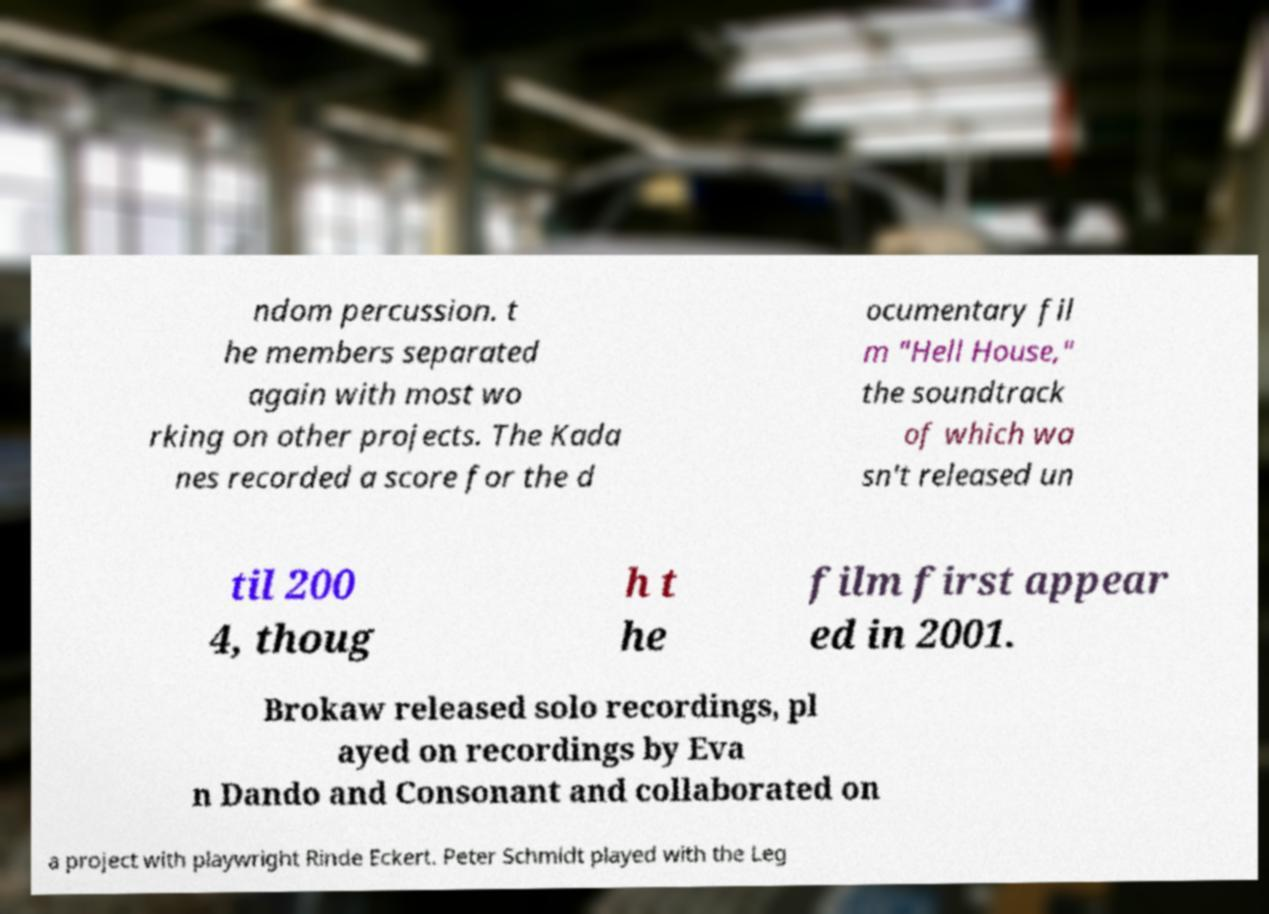What messages or text are displayed in this image? I need them in a readable, typed format. ndom percussion. t he members separated again with most wo rking on other projects. The Kada nes recorded a score for the d ocumentary fil m "Hell House," the soundtrack of which wa sn't released un til 200 4, thoug h t he film first appear ed in 2001. Brokaw released solo recordings, pl ayed on recordings by Eva n Dando and Consonant and collaborated on a project with playwright Rinde Eckert. Peter Schmidt played with the Leg 